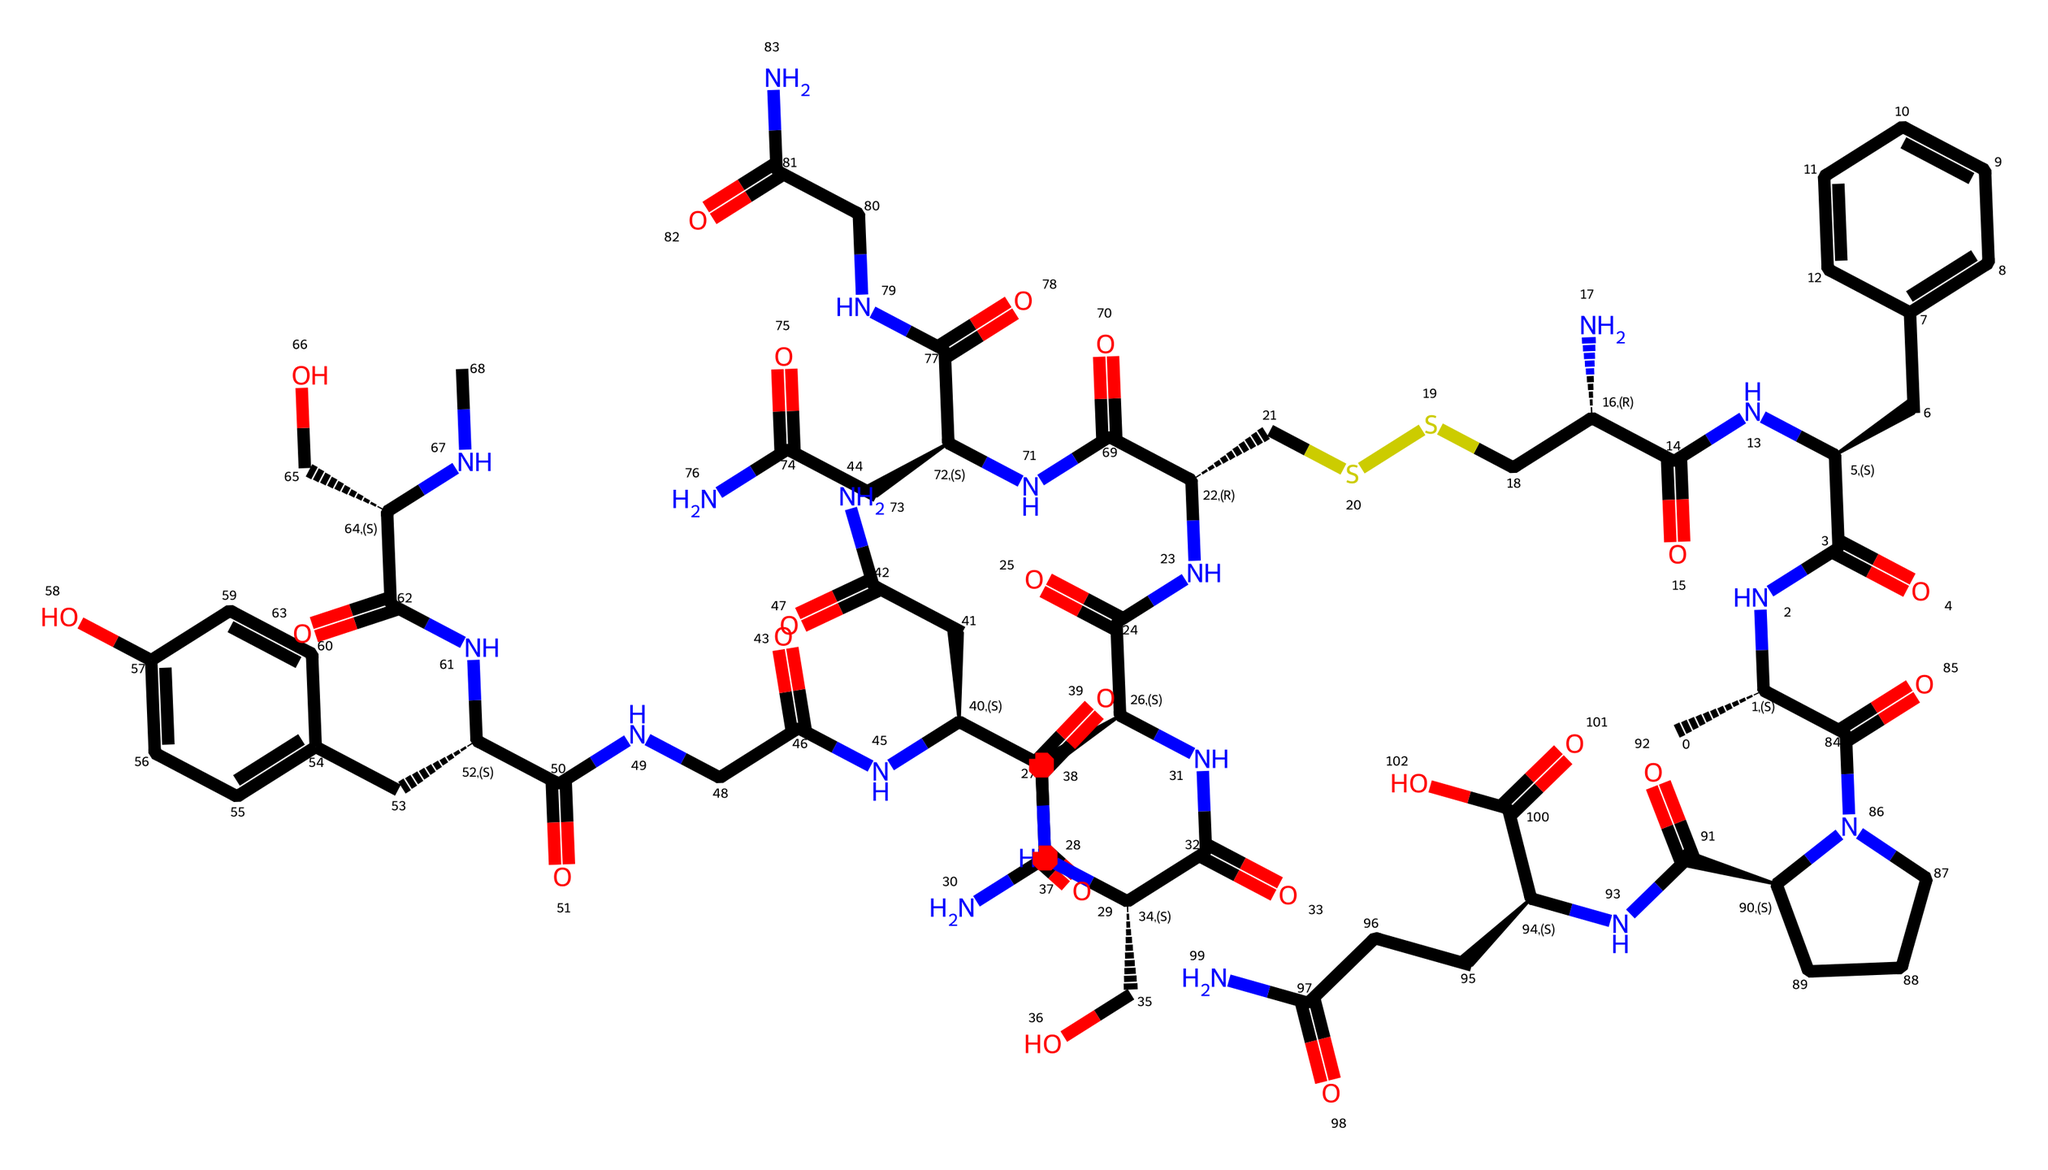What is the molecular weight of oxytocin based on its structure? To determine the molecular weight, we can sum the atomic weights of all atoms present in the chemical structure. The relevant atoms include carbon (C), hydrogen (H), nitrogen (N), oxygen (O), and sulfur (S). After careful calculation based on the SMILES representation provided, the molecular weight is approximately 1007.
Answer: 1007 How many nitrogen atoms are present in the structure of oxytocin? By analyzing the SMILES representation, we can count the nitrogen (N) symbols, which indicate the presence of nitrogen atoms in the structure. In this case, there are 11 nitrogen atoms throughout the molecule.
Answer: 11 What type of bond predominantly holds the oxytocin structure together? The dominant type of bond in the oxytocin structure is covalent bonds. This can be inferred by the presence of carbon, nitrogen, and other atom connections reflected in the structure, suggesting sharing of electron pairs among atoms.
Answer: covalent How many sulfur atoms are present in oxytocin? Upon reviewing the SMILES string, we look for the sulfur (S) symbol. In this case, there is one sulfur atom within the structure of oxytocin.
Answer: 1 What is the functional group associated with the nitrogen in oxytocin? The nitrogen atoms in oxytocin are predominantly part of amide functional groups, as indicated by the nitrogen bonded to carbonyl (C=O) groups. These connections identify the presence of amides within the entire structure.
Answer: amide How many chiral centers are present in oxytocin? To determine the number of chiral centers, we need to look for carbon atoms that are bonded to four different substituents. By examining the chemical structure, we can identify a total of three chiral centers.
Answer: 3 